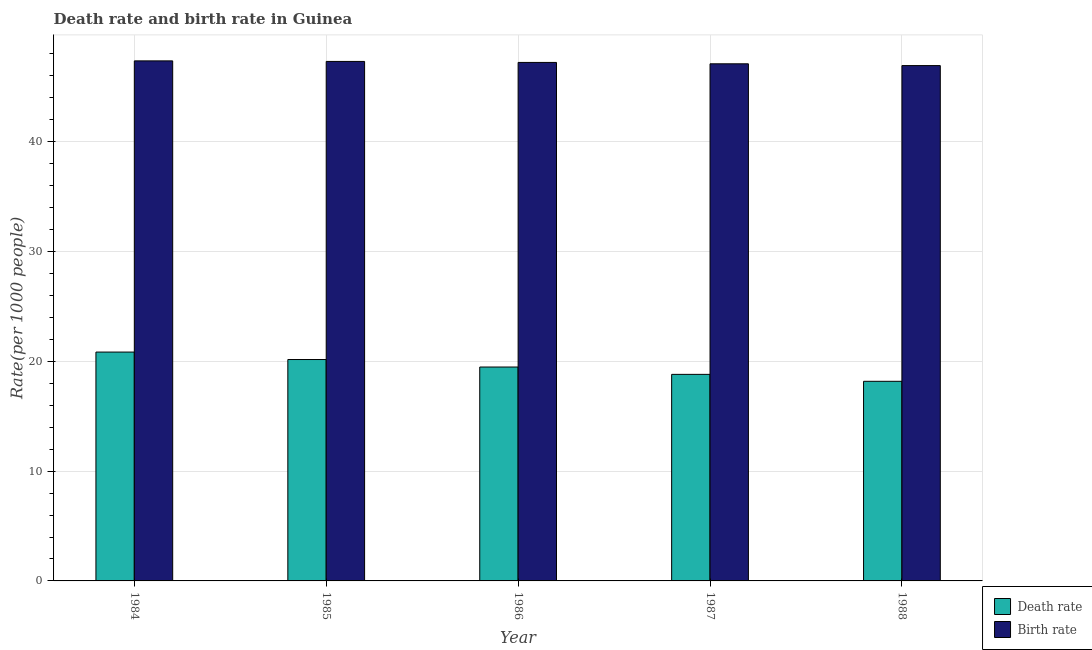How many different coloured bars are there?
Offer a terse response. 2. What is the death rate in 1988?
Your response must be concise. 18.18. Across all years, what is the maximum death rate?
Give a very brief answer. 20.84. Across all years, what is the minimum birth rate?
Provide a short and direct response. 46.94. In which year was the birth rate maximum?
Offer a very short reply. 1984. In which year was the death rate minimum?
Give a very brief answer. 1988. What is the total birth rate in the graph?
Ensure brevity in your answer.  235.95. What is the difference between the birth rate in 1984 and that in 1985?
Your answer should be very brief. 0.05. What is the difference between the birth rate in 1986 and the death rate in 1987?
Give a very brief answer. 0.13. What is the average death rate per year?
Provide a short and direct response. 19.5. In how many years, is the birth rate greater than 44?
Make the answer very short. 5. What is the ratio of the death rate in 1985 to that in 1986?
Offer a very short reply. 1.04. Is the difference between the death rate in 1987 and 1988 greater than the difference between the birth rate in 1987 and 1988?
Your answer should be very brief. No. What is the difference between the highest and the second highest birth rate?
Ensure brevity in your answer.  0.05. What is the difference between the highest and the lowest death rate?
Offer a very short reply. 2.66. In how many years, is the birth rate greater than the average birth rate taken over all years?
Offer a very short reply. 3. What does the 1st bar from the left in 1985 represents?
Give a very brief answer. Death rate. What does the 1st bar from the right in 1988 represents?
Offer a very short reply. Birth rate. How many years are there in the graph?
Make the answer very short. 5. What is the difference between two consecutive major ticks on the Y-axis?
Your answer should be very brief. 10. Are the values on the major ticks of Y-axis written in scientific E-notation?
Keep it short and to the point. No. How many legend labels are there?
Provide a short and direct response. 2. How are the legend labels stacked?
Ensure brevity in your answer.  Vertical. What is the title of the graph?
Give a very brief answer. Death rate and birth rate in Guinea. What is the label or title of the X-axis?
Make the answer very short. Year. What is the label or title of the Y-axis?
Your response must be concise. Rate(per 1000 people). What is the Rate(per 1000 people) of Death rate in 1984?
Your answer should be compact. 20.84. What is the Rate(per 1000 people) of Birth rate in 1984?
Provide a short and direct response. 47.37. What is the Rate(per 1000 people) in Death rate in 1985?
Provide a short and direct response. 20.17. What is the Rate(per 1000 people) of Birth rate in 1985?
Ensure brevity in your answer.  47.32. What is the Rate(per 1000 people) in Death rate in 1986?
Your response must be concise. 19.48. What is the Rate(per 1000 people) in Birth rate in 1986?
Make the answer very short. 47.23. What is the Rate(per 1000 people) in Death rate in 1987?
Your response must be concise. 18.81. What is the Rate(per 1000 people) of Birth rate in 1987?
Your answer should be very brief. 47.1. What is the Rate(per 1000 people) in Death rate in 1988?
Your answer should be compact. 18.18. What is the Rate(per 1000 people) of Birth rate in 1988?
Your response must be concise. 46.94. Across all years, what is the maximum Rate(per 1000 people) of Death rate?
Provide a succinct answer. 20.84. Across all years, what is the maximum Rate(per 1000 people) in Birth rate?
Offer a very short reply. 47.37. Across all years, what is the minimum Rate(per 1000 people) of Death rate?
Your response must be concise. 18.18. Across all years, what is the minimum Rate(per 1000 people) of Birth rate?
Keep it short and to the point. 46.94. What is the total Rate(per 1000 people) of Death rate in the graph?
Give a very brief answer. 97.49. What is the total Rate(per 1000 people) of Birth rate in the graph?
Offer a terse response. 235.95. What is the difference between the Rate(per 1000 people) of Death rate in 1984 and that in 1985?
Provide a short and direct response. 0.68. What is the difference between the Rate(per 1000 people) of Birth rate in 1984 and that in 1985?
Your answer should be compact. 0.05. What is the difference between the Rate(per 1000 people) in Death rate in 1984 and that in 1986?
Offer a terse response. 1.36. What is the difference between the Rate(per 1000 people) of Birth rate in 1984 and that in 1986?
Offer a terse response. 0.14. What is the difference between the Rate(per 1000 people) in Death rate in 1984 and that in 1987?
Provide a short and direct response. 2.03. What is the difference between the Rate(per 1000 people) in Birth rate in 1984 and that in 1987?
Provide a short and direct response. 0.27. What is the difference between the Rate(per 1000 people) in Death rate in 1984 and that in 1988?
Your answer should be compact. 2.66. What is the difference between the Rate(per 1000 people) of Birth rate in 1984 and that in 1988?
Ensure brevity in your answer.  0.43. What is the difference between the Rate(per 1000 people) in Death rate in 1985 and that in 1986?
Your answer should be very brief. 0.68. What is the difference between the Rate(per 1000 people) in Birth rate in 1985 and that in 1986?
Give a very brief answer. 0.09. What is the difference between the Rate(per 1000 people) of Death rate in 1985 and that in 1987?
Your answer should be compact. 1.35. What is the difference between the Rate(per 1000 people) in Birth rate in 1985 and that in 1987?
Your response must be concise. 0.22. What is the difference between the Rate(per 1000 people) in Death rate in 1985 and that in 1988?
Your answer should be very brief. 1.98. What is the difference between the Rate(per 1000 people) in Birth rate in 1985 and that in 1988?
Make the answer very short. 0.38. What is the difference between the Rate(per 1000 people) in Death rate in 1986 and that in 1987?
Your response must be concise. 0.67. What is the difference between the Rate(per 1000 people) of Birth rate in 1986 and that in 1987?
Your answer should be compact. 0.13. What is the difference between the Rate(per 1000 people) in Death rate in 1986 and that in 1988?
Make the answer very short. 1.3. What is the difference between the Rate(per 1000 people) of Birth rate in 1986 and that in 1988?
Offer a terse response. 0.29. What is the difference between the Rate(per 1000 people) of Death rate in 1987 and that in 1988?
Provide a short and direct response. 0.63. What is the difference between the Rate(per 1000 people) of Birth rate in 1987 and that in 1988?
Provide a short and direct response. 0.16. What is the difference between the Rate(per 1000 people) of Death rate in 1984 and the Rate(per 1000 people) of Birth rate in 1985?
Ensure brevity in your answer.  -26.47. What is the difference between the Rate(per 1000 people) in Death rate in 1984 and the Rate(per 1000 people) in Birth rate in 1986?
Offer a very short reply. -26.38. What is the difference between the Rate(per 1000 people) of Death rate in 1984 and the Rate(per 1000 people) of Birth rate in 1987?
Your answer should be compact. -26.25. What is the difference between the Rate(per 1000 people) in Death rate in 1984 and the Rate(per 1000 people) in Birth rate in 1988?
Offer a terse response. -26.09. What is the difference between the Rate(per 1000 people) in Death rate in 1985 and the Rate(per 1000 people) in Birth rate in 1986?
Keep it short and to the point. -27.06. What is the difference between the Rate(per 1000 people) of Death rate in 1985 and the Rate(per 1000 people) of Birth rate in 1987?
Your response must be concise. -26.93. What is the difference between the Rate(per 1000 people) of Death rate in 1985 and the Rate(per 1000 people) of Birth rate in 1988?
Keep it short and to the point. -26.77. What is the difference between the Rate(per 1000 people) in Death rate in 1986 and the Rate(per 1000 people) in Birth rate in 1987?
Your answer should be compact. -27.62. What is the difference between the Rate(per 1000 people) of Death rate in 1986 and the Rate(per 1000 people) of Birth rate in 1988?
Offer a very short reply. -27.46. What is the difference between the Rate(per 1000 people) of Death rate in 1987 and the Rate(per 1000 people) of Birth rate in 1988?
Your answer should be very brief. -28.12. What is the average Rate(per 1000 people) of Death rate per year?
Your answer should be compact. 19.5. What is the average Rate(per 1000 people) of Birth rate per year?
Ensure brevity in your answer.  47.19. In the year 1984, what is the difference between the Rate(per 1000 people) of Death rate and Rate(per 1000 people) of Birth rate?
Ensure brevity in your answer.  -26.52. In the year 1985, what is the difference between the Rate(per 1000 people) in Death rate and Rate(per 1000 people) in Birth rate?
Offer a terse response. -27.15. In the year 1986, what is the difference between the Rate(per 1000 people) in Death rate and Rate(per 1000 people) in Birth rate?
Keep it short and to the point. -27.74. In the year 1987, what is the difference between the Rate(per 1000 people) in Death rate and Rate(per 1000 people) in Birth rate?
Ensure brevity in your answer.  -28.29. In the year 1988, what is the difference between the Rate(per 1000 people) in Death rate and Rate(per 1000 people) in Birth rate?
Keep it short and to the point. -28.76. What is the ratio of the Rate(per 1000 people) of Death rate in 1984 to that in 1985?
Offer a terse response. 1.03. What is the ratio of the Rate(per 1000 people) of Birth rate in 1984 to that in 1985?
Provide a short and direct response. 1. What is the ratio of the Rate(per 1000 people) of Death rate in 1984 to that in 1986?
Make the answer very short. 1.07. What is the ratio of the Rate(per 1000 people) in Birth rate in 1984 to that in 1986?
Ensure brevity in your answer.  1. What is the ratio of the Rate(per 1000 people) in Death rate in 1984 to that in 1987?
Your answer should be compact. 1.11. What is the ratio of the Rate(per 1000 people) in Death rate in 1984 to that in 1988?
Your response must be concise. 1.15. What is the ratio of the Rate(per 1000 people) in Birth rate in 1984 to that in 1988?
Offer a very short reply. 1.01. What is the ratio of the Rate(per 1000 people) in Death rate in 1985 to that in 1986?
Give a very brief answer. 1.04. What is the ratio of the Rate(per 1000 people) in Death rate in 1985 to that in 1987?
Make the answer very short. 1.07. What is the ratio of the Rate(per 1000 people) of Death rate in 1985 to that in 1988?
Your answer should be very brief. 1.11. What is the ratio of the Rate(per 1000 people) of Death rate in 1986 to that in 1987?
Give a very brief answer. 1.04. What is the ratio of the Rate(per 1000 people) of Birth rate in 1986 to that in 1987?
Your answer should be compact. 1. What is the ratio of the Rate(per 1000 people) in Death rate in 1986 to that in 1988?
Your answer should be compact. 1.07. What is the ratio of the Rate(per 1000 people) in Birth rate in 1986 to that in 1988?
Give a very brief answer. 1.01. What is the ratio of the Rate(per 1000 people) of Death rate in 1987 to that in 1988?
Your answer should be very brief. 1.03. What is the difference between the highest and the second highest Rate(per 1000 people) in Death rate?
Your response must be concise. 0.68. What is the difference between the highest and the second highest Rate(per 1000 people) in Birth rate?
Offer a terse response. 0.05. What is the difference between the highest and the lowest Rate(per 1000 people) of Death rate?
Ensure brevity in your answer.  2.66. What is the difference between the highest and the lowest Rate(per 1000 people) of Birth rate?
Your answer should be compact. 0.43. 